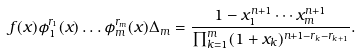<formula> <loc_0><loc_0><loc_500><loc_500>f ( { x } ) \phi _ { 1 } ^ { r _ { 1 } } ( { x } ) \dots \phi _ { m } ^ { r _ { m } } ( { x } ) \Delta _ { m } = \frac { 1 - x _ { 1 } ^ { n + 1 } \cdots x _ { m } ^ { n + 1 } } { \prod _ { k = 1 } ^ { m } ( 1 + x _ { k } ) ^ { n + 1 - r _ { k } - r _ { k + 1 } } } .</formula> 